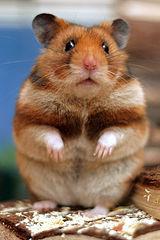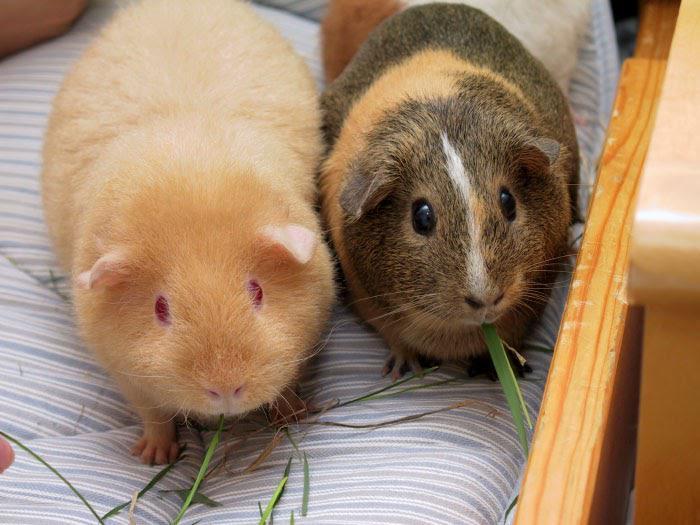The first image is the image on the left, the second image is the image on the right. Evaluate the accuracy of this statement regarding the images: "At least one of the animals is sitting on a soft cushioned material.". Is it true? Answer yes or no. Yes. 